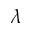Convert formula to latex. <formula><loc_0><loc_0><loc_500><loc_500>\lambda</formula> 